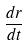<formula> <loc_0><loc_0><loc_500><loc_500>\frac { d r } { d t }</formula> 